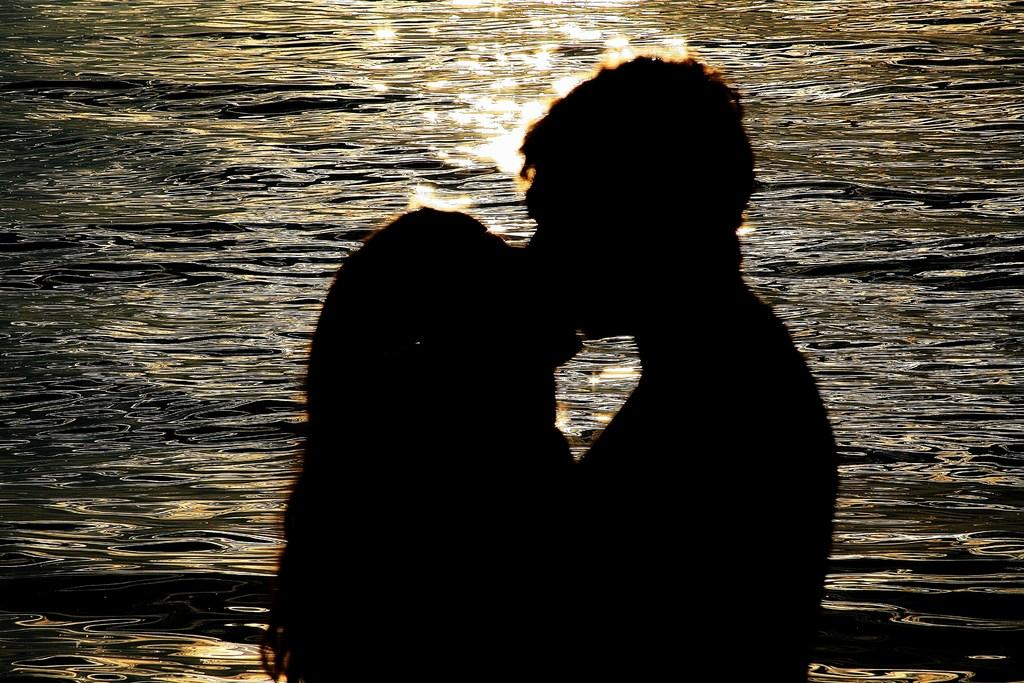Who is present in the image? There is a couple in the image. What are the couple doing in the image? The couple is kissing. Where does the scene take place? The scene takes place on the sea shore. What type of nut can be seen in the couple's hands in the image? There is no nut present in the image; the couple is kissing on the sea shore. 